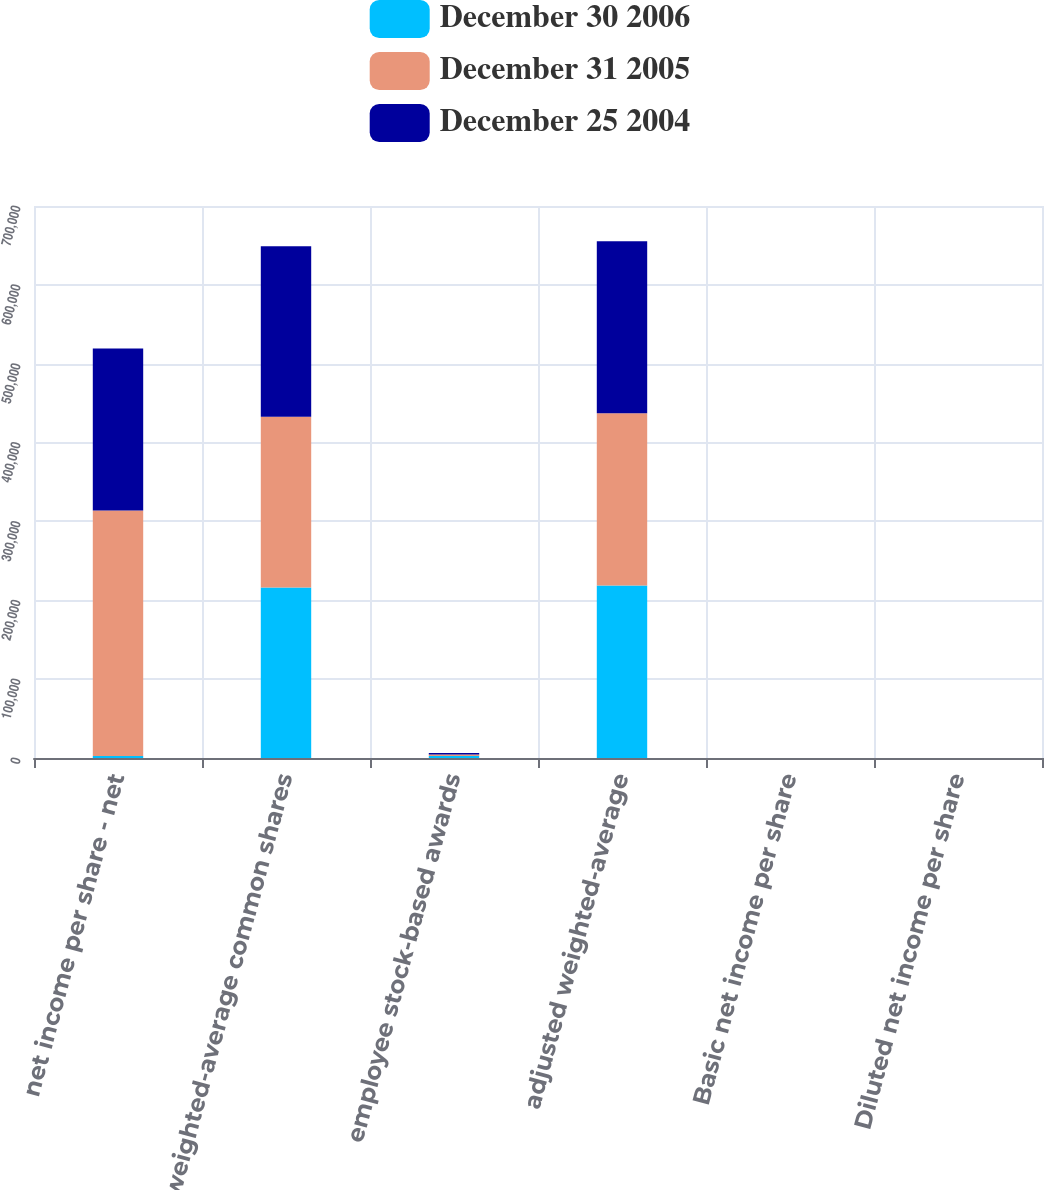Convert chart. <chart><loc_0><loc_0><loc_500><loc_500><stacked_bar_chart><ecel><fcel>net income per share - net<fcel>weighted-average common shares<fcel>employee stock-based awards<fcel>adjusted weighted-average<fcel>Basic net income per share<fcel>Diluted net income per share<nl><fcel>December 30 2006<fcel>2505<fcel>216340<fcel>2505<fcel>218845<fcel>2.38<fcel>2.35<nl><fcel>December 31 2005<fcel>311219<fcel>216294<fcel>1942<fcel>218236<fcel>1.44<fcel>1.43<nl><fcel>December 25 2004<fcel>205700<fcel>216322<fcel>1738<fcel>218060<fcel>0.95<fcel>0.94<nl></chart> 